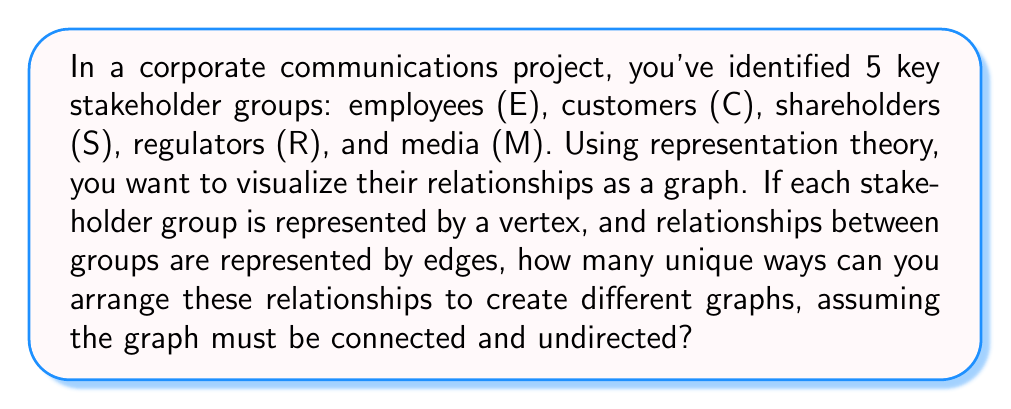What is the answer to this math problem? To solve this problem, we'll use concepts from representation theory and graph theory:

1. First, we need to understand that we're dealing with labeled graphs on 5 vertices.

2. The graph must be connected, which means it must have at least 4 edges (a tree).

3. The maximum number of edges in an undirected graph with 5 vertices is $\binom{5}{2} = 10$.

4. For each number of edges from 4 to 10, we need to calculate the number of possible arrangements:

   a) For 4 edges: This is the number of labeled trees on 5 vertices, given by Cayley's formula: $n^{n-2} = 5^3 = 125$

   b) For 5 to 10 edges: We use the formula for the number of labeled graphs with n vertices and k edges:
      $$\binom{\binom{n}{2}}{k}$$

      So we calculate:
      5 edges: $\binom{10}{5} = 252$
      6 edges: $\binom{10}{6} = 210$
      7 edges: $\binom{10}{7} = 120$
      8 edges: $\binom{10}{8} = 45$
      9 edges: $\binom{10}{9} = 10$
      10 edges: $\binom{10}{10} = 1$

5. The total number of unique graphs is the sum of all these possibilities:
   $125 + 252 + 210 + 120 + 45 + 10 + 1 = 763$

This result represents all possible ways to visualize the relationships between the stakeholder groups, from the minimum connected configuration to the fully connected graph.
Answer: 763 unique graphs 